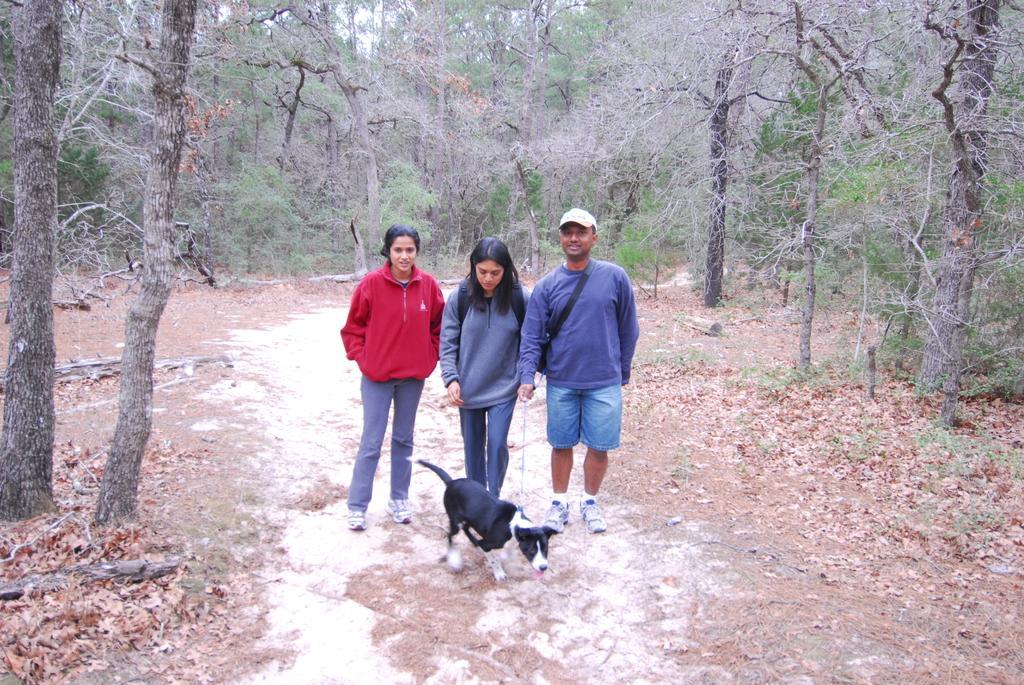How would you summarize this image in a sentence or two? This picture shows few people standing and we see a man wore a cap on his head and a bag and he is holding a dog with a string. The dog is so white and black in color and we see trees and few dry leaves on the ground. 